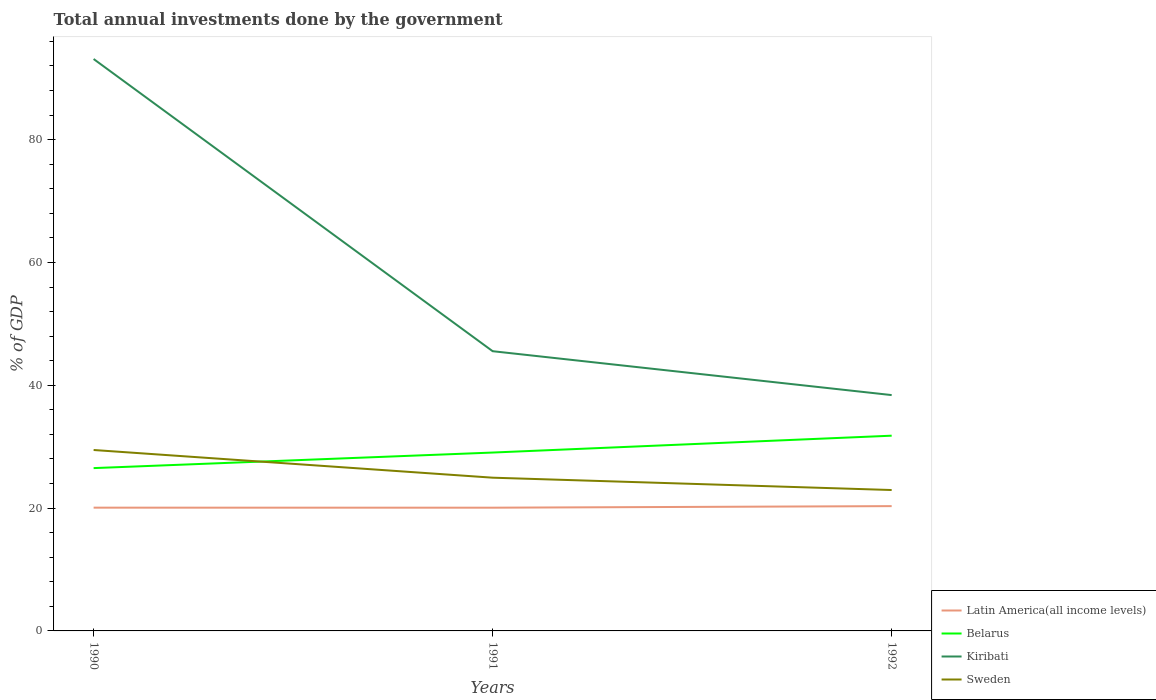Does the line corresponding to Kiribati intersect with the line corresponding to Latin America(all income levels)?
Offer a terse response. No. Is the number of lines equal to the number of legend labels?
Keep it short and to the point. Yes. Across all years, what is the maximum total annual investments done by the government in Kiribati?
Your answer should be compact. 38.4. What is the total total annual investments done by the government in Latin America(all income levels) in the graph?
Offer a very short reply. 0. What is the difference between the highest and the second highest total annual investments done by the government in Belarus?
Offer a very short reply. 5.28. What is the difference between the highest and the lowest total annual investments done by the government in Kiribati?
Your answer should be compact. 1. Is the total annual investments done by the government in Sweden strictly greater than the total annual investments done by the government in Kiribati over the years?
Ensure brevity in your answer.  Yes. How many lines are there?
Your response must be concise. 4. Where does the legend appear in the graph?
Keep it short and to the point. Bottom right. What is the title of the graph?
Provide a short and direct response. Total annual investments done by the government. Does "Central African Republic" appear as one of the legend labels in the graph?
Ensure brevity in your answer.  No. What is the label or title of the X-axis?
Offer a very short reply. Years. What is the label or title of the Y-axis?
Keep it short and to the point. % of GDP. What is the % of GDP in Latin America(all income levels) in 1990?
Make the answer very short. 20.07. What is the % of GDP of Belarus in 1990?
Ensure brevity in your answer.  26.51. What is the % of GDP in Kiribati in 1990?
Ensure brevity in your answer.  93.13. What is the % of GDP of Sweden in 1990?
Make the answer very short. 29.46. What is the % of GDP in Latin America(all income levels) in 1991?
Offer a very short reply. 20.07. What is the % of GDP of Belarus in 1991?
Offer a very short reply. 29.05. What is the % of GDP in Kiribati in 1991?
Keep it short and to the point. 45.55. What is the % of GDP in Sweden in 1991?
Provide a short and direct response. 24.95. What is the % of GDP in Latin America(all income levels) in 1992?
Offer a terse response. 20.32. What is the % of GDP of Belarus in 1992?
Ensure brevity in your answer.  31.79. What is the % of GDP of Kiribati in 1992?
Provide a succinct answer. 38.4. What is the % of GDP of Sweden in 1992?
Ensure brevity in your answer.  22.94. Across all years, what is the maximum % of GDP of Latin America(all income levels)?
Your response must be concise. 20.32. Across all years, what is the maximum % of GDP of Belarus?
Give a very brief answer. 31.79. Across all years, what is the maximum % of GDP in Kiribati?
Provide a succinct answer. 93.13. Across all years, what is the maximum % of GDP in Sweden?
Your answer should be compact. 29.46. Across all years, what is the minimum % of GDP in Latin America(all income levels)?
Your response must be concise. 20.07. Across all years, what is the minimum % of GDP in Belarus?
Ensure brevity in your answer.  26.51. Across all years, what is the minimum % of GDP in Kiribati?
Your response must be concise. 38.4. Across all years, what is the minimum % of GDP in Sweden?
Ensure brevity in your answer.  22.94. What is the total % of GDP of Latin America(all income levels) in the graph?
Offer a very short reply. 60.46. What is the total % of GDP of Belarus in the graph?
Keep it short and to the point. 87.35. What is the total % of GDP in Kiribati in the graph?
Make the answer very short. 177.08. What is the total % of GDP of Sweden in the graph?
Ensure brevity in your answer.  77.36. What is the difference between the % of GDP in Latin America(all income levels) in 1990 and that in 1991?
Make the answer very short. 0. What is the difference between the % of GDP of Belarus in 1990 and that in 1991?
Provide a succinct answer. -2.53. What is the difference between the % of GDP of Kiribati in 1990 and that in 1991?
Offer a very short reply. 47.58. What is the difference between the % of GDP in Sweden in 1990 and that in 1991?
Provide a short and direct response. 4.51. What is the difference between the % of GDP in Latin America(all income levels) in 1990 and that in 1992?
Your answer should be compact. -0.25. What is the difference between the % of GDP of Belarus in 1990 and that in 1992?
Your answer should be very brief. -5.28. What is the difference between the % of GDP in Kiribati in 1990 and that in 1992?
Give a very brief answer. 54.73. What is the difference between the % of GDP in Sweden in 1990 and that in 1992?
Your answer should be compact. 6.52. What is the difference between the % of GDP in Latin America(all income levels) in 1991 and that in 1992?
Provide a succinct answer. -0.25. What is the difference between the % of GDP of Belarus in 1991 and that in 1992?
Make the answer very short. -2.74. What is the difference between the % of GDP in Kiribati in 1991 and that in 1992?
Your response must be concise. 7.15. What is the difference between the % of GDP in Sweden in 1991 and that in 1992?
Provide a short and direct response. 2.01. What is the difference between the % of GDP of Latin America(all income levels) in 1990 and the % of GDP of Belarus in 1991?
Offer a very short reply. -8.97. What is the difference between the % of GDP in Latin America(all income levels) in 1990 and the % of GDP in Kiribati in 1991?
Ensure brevity in your answer.  -25.48. What is the difference between the % of GDP in Latin America(all income levels) in 1990 and the % of GDP in Sweden in 1991?
Provide a short and direct response. -4.88. What is the difference between the % of GDP of Belarus in 1990 and the % of GDP of Kiribati in 1991?
Your answer should be very brief. -19.04. What is the difference between the % of GDP in Belarus in 1990 and the % of GDP in Sweden in 1991?
Give a very brief answer. 1.56. What is the difference between the % of GDP in Kiribati in 1990 and the % of GDP in Sweden in 1991?
Keep it short and to the point. 68.18. What is the difference between the % of GDP in Latin America(all income levels) in 1990 and the % of GDP in Belarus in 1992?
Offer a very short reply. -11.72. What is the difference between the % of GDP of Latin America(all income levels) in 1990 and the % of GDP of Kiribati in 1992?
Offer a terse response. -18.33. What is the difference between the % of GDP of Latin America(all income levels) in 1990 and the % of GDP of Sweden in 1992?
Provide a succinct answer. -2.87. What is the difference between the % of GDP in Belarus in 1990 and the % of GDP in Kiribati in 1992?
Provide a succinct answer. -11.89. What is the difference between the % of GDP of Belarus in 1990 and the % of GDP of Sweden in 1992?
Your answer should be compact. 3.57. What is the difference between the % of GDP of Kiribati in 1990 and the % of GDP of Sweden in 1992?
Offer a very short reply. 70.19. What is the difference between the % of GDP of Latin America(all income levels) in 1991 and the % of GDP of Belarus in 1992?
Keep it short and to the point. -11.72. What is the difference between the % of GDP in Latin America(all income levels) in 1991 and the % of GDP in Kiribati in 1992?
Ensure brevity in your answer.  -18.33. What is the difference between the % of GDP of Latin America(all income levels) in 1991 and the % of GDP of Sweden in 1992?
Your answer should be very brief. -2.88. What is the difference between the % of GDP of Belarus in 1991 and the % of GDP of Kiribati in 1992?
Ensure brevity in your answer.  -9.36. What is the difference between the % of GDP in Belarus in 1991 and the % of GDP in Sweden in 1992?
Offer a very short reply. 6.1. What is the difference between the % of GDP in Kiribati in 1991 and the % of GDP in Sweden in 1992?
Offer a terse response. 22.61. What is the average % of GDP of Latin America(all income levels) per year?
Make the answer very short. 20.15. What is the average % of GDP of Belarus per year?
Keep it short and to the point. 29.12. What is the average % of GDP in Kiribati per year?
Offer a terse response. 59.03. What is the average % of GDP of Sweden per year?
Ensure brevity in your answer.  25.79. In the year 1990, what is the difference between the % of GDP of Latin America(all income levels) and % of GDP of Belarus?
Offer a terse response. -6.44. In the year 1990, what is the difference between the % of GDP in Latin America(all income levels) and % of GDP in Kiribati?
Offer a terse response. -73.06. In the year 1990, what is the difference between the % of GDP of Latin America(all income levels) and % of GDP of Sweden?
Ensure brevity in your answer.  -9.39. In the year 1990, what is the difference between the % of GDP in Belarus and % of GDP in Kiribati?
Your response must be concise. -66.62. In the year 1990, what is the difference between the % of GDP in Belarus and % of GDP in Sweden?
Make the answer very short. -2.95. In the year 1990, what is the difference between the % of GDP of Kiribati and % of GDP of Sweden?
Offer a terse response. 63.67. In the year 1991, what is the difference between the % of GDP in Latin America(all income levels) and % of GDP in Belarus?
Offer a terse response. -8.98. In the year 1991, what is the difference between the % of GDP in Latin America(all income levels) and % of GDP in Kiribati?
Your response must be concise. -25.48. In the year 1991, what is the difference between the % of GDP in Latin America(all income levels) and % of GDP in Sweden?
Your answer should be very brief. -4.88. In the year 1991, what is the difference between the % of GDP of Belarus and % of GDP of Kiribati?
Ensure brevity in your answer.  -16.5. In the year 1991, what is the difference between the % of GDP of Belarus and % of GDP of Sweden?
Ensure brevity in your answer.  4.1. In the year 1991, what is the difference between the % of GDP in Kiribati and % of GDP in Sweden?
Your response must be concise. 20.6. In the year 1992, what is the difference between the % of GDP of Latin America(all income levels) and % of GDP of Belarus?
Offer a very short reply. -11.47. In the year 1992, what is the difference between the % of GDP of Latin America(all income levels) and % of GDP of Kiribati?
Your response must be concise. -18.08. In the year 1992, what is the difference between the % of GDP of Latin America(all income levels) and % of GDP of Sweden?
Ensure brevity in your answer.  -2.62. In the year 1992, what is the difference between the % of GDP in Belarus and % of GDP in Kiribati?
Offer a very short reply. -6.61. In the year 1992, what is the difference between the % of GDP in Belarus and % of GDP in Sweden?
Ensure brevity in your answer.  8.85. In the year 1992, what is the difference between the % of GDP of Kiribati and % of GDP of Sweden?
Your answer should be very brief. 15.46. What is the ratio of the % of GDP of Latin America(all income levels) in 1990 to that in 1991?
Provide a succinct answer. 1. What is the ratio of the % of GDP in Belarus in 1990 to that in 1991?
Your answer should be compact. 0.91. What is the ratio of the % of GDP in Kiribati in 1990 to that in 1991?
Provide a short and direct response. 2.04. What is the ratio of the % of GDP in Sweden in 1990 to that in 1991?
Your response must be concise. 1.18. What is the ratio of the % of GDP in Belarus in 1990 to that in 1992?
Ensure brevity in your answer.  0.83. What is the ratio of the % of GDP in Kiribati in 1990 to that in 1992?
Keep it short and to the point. 2.43. What is the ratio of the % of GDP of Sweden in 1990 to that in 1992?
Keep it short and to the point. 1.28. What is the ratio of the % of GDP of Latin America(all income levels) in 1991 to that in 1992?
Ensure brevity in your answer.  0.99. What is the ratio of the % of GDP of Belarus in 1991 to that in 1992?
Keep it short and to the point. 0.91. What is the ratio of the % of GDP of Kiribati in 1991 to that in 1992?
Ensure brevity in your answer.  1.19. What is the ratio of the % of GDP in Sweden in 1991 to that in 1992?
Ensure brevity in your answer.  1.09. What is the difference between the highest and the second highest % of GDP of Latin America(all income levels)?
Provide a succinct answer. 0.25. What is the difference between the highest and the second highest % of GDP in Belarus?
Your answer should be very brief. 2.74. What is the difference between the highest and the second highest % of GDP of Kiribati?
Offer a terse response. 47.58. What is the difference between the highest and the second highest % of GDP of Sweden?
Ensure brevity in your answer.  4.51. What is the difference between the highest and the lowest % of GDP of Latin America(all income levels)?
Give a very brief answer. 0.25. What is the difference between the highest and the lowest % of GDP in Belarus?
Ensure brevity in your answer.  5.28. What is the difference between the highest and the lowest % of GDP of Kiribati?
Give a very brief answer. 54.73. What is the difference between the highest and the lowest % of GDP in Sweden?
Your response must be concise. 6.52. 